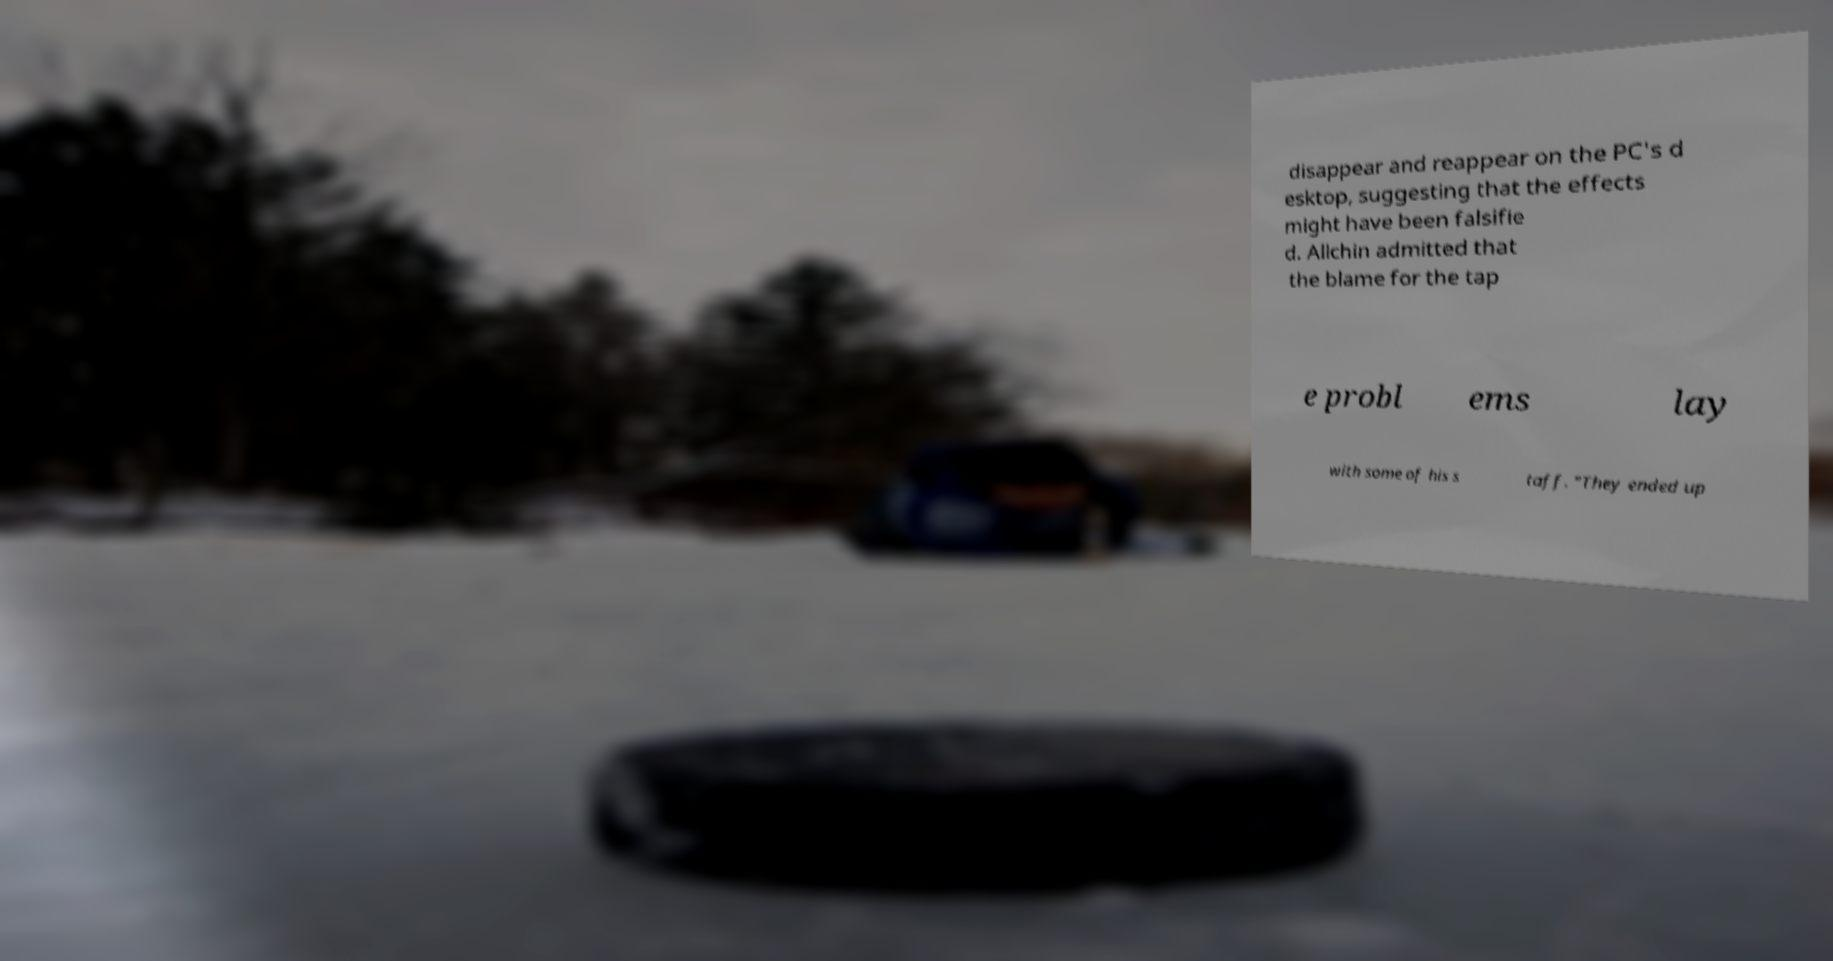Can you read and provide the text displayed in the image?This photo seems to have some interesting text. Can you extract and type it out for me? disappear and reappear on the PC's d esktop, suggesting that the effects might have been falsifie d. Allchin admitted that the blame for the tap e probl ems lay with some of his s taff. "They ended up 